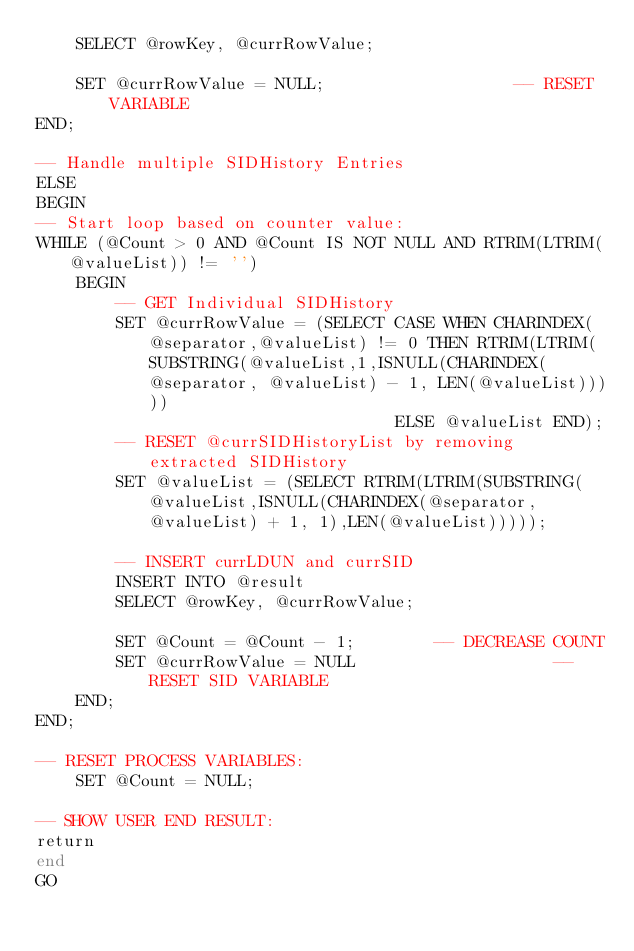Convert code to text. <code><loc_0><loc_0><loc_500><loc_500><_SQL_>	SELECT @rowKey, @currRowValue;
	
	SET @currRowValue = NULL;					-- RESET VARIABLE
END;

-- Handle multiple SIDHistory Entries
ELSE
BEGIN
-- Start loop based on counter value:
WHILE (@Count > 0 AND @Count IS NOT NULL AND RTRIM(LTRIM(@valueList)) != '')
	BEGIN
		-- GET Individual SIDHistory
		SET @currRowValue = (SELECT CASE WHEN CHARINDEX(@separator,@valueList) != 0 THEN RTRIM(LTRIM(SUBSTRING(@valueList,1,ISNULL(CHARINDEX(@separator, @valueList) - 1, LEN(@valueList)))))
									ELSE @valueList END);
		-- RESET @currSIDHistoryList by removing extracted SIDHistory
		SET @valueList = (SELECT RTRIM(LTRIM(SUBSTRING(@valueList,ISNULL(CHARINDEX(@separator, @valueList) + 1, 1),LEN(@valueList)))));

		-- INSERT currLDUN and currSID
		INSERT INTO @result
		SELECT @rowKey, @currRowValue;

		SET @Count = @Count - 1;		-- DECREASE COUNT
		SET @currRowValue = NULL					-- RESET SID VARIABLE
	END;
END;

-- RESET PROCESS VARIABLES:
	SET	@Count = NULL;

-- SHOW USER END RESULT:
return
end
GO


</code> 